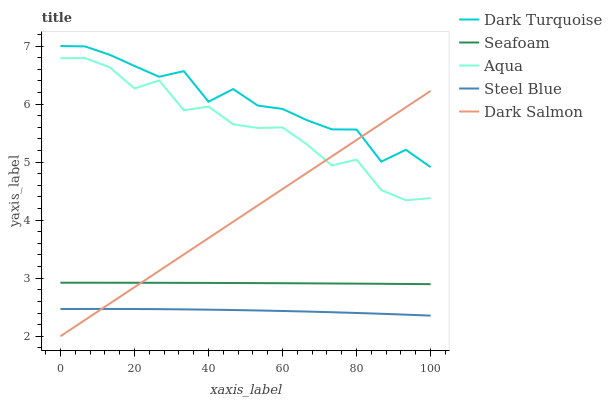Does Steel Blue have the minimum area under the curve?
Answer yes or no. Yes. Does Dark Turquoise have the maximum area under the curve?
Answer yes or no. Yes. Does Dark Salmon have the minimum area under the curve?
Answer yes or no. No. Does Dark Salmon have the maximum area under the curve?
Answer yes or no. No. Is Dark Salmon the smoothest?
Answer yes or no. Yes. Is Aqua the roughest?
Answer yes or no. Yes. Is Aqua the smoothest?
Answer yes or no. No. Is Dark Salmon the roughest?
Answer yes or no. No. Does Aqua have the lowest value?
Answer yes or no. No. Does Dark Turquoise have the highest value?
Answer yes or no. Yes. Does Dark Salmon have the highest value?
Answer yes or no. No. Is Steel Blue less than Aqua?
Answer yes or no. Yes. Is Dark Turquoise greater than Steel Blue?
Answer yes or no. Yes. Does Steel Blue intersect Dark Salmon?
Answer yes or no. Yes. Is Steel Blue less than Dark Salmon?
Answer yes or no. No. Is Steel Blue greater than Dark Salmon?
Answer yes or no. No. Does Steel Blue intersect Aqua?
Answer yes or no. No. 